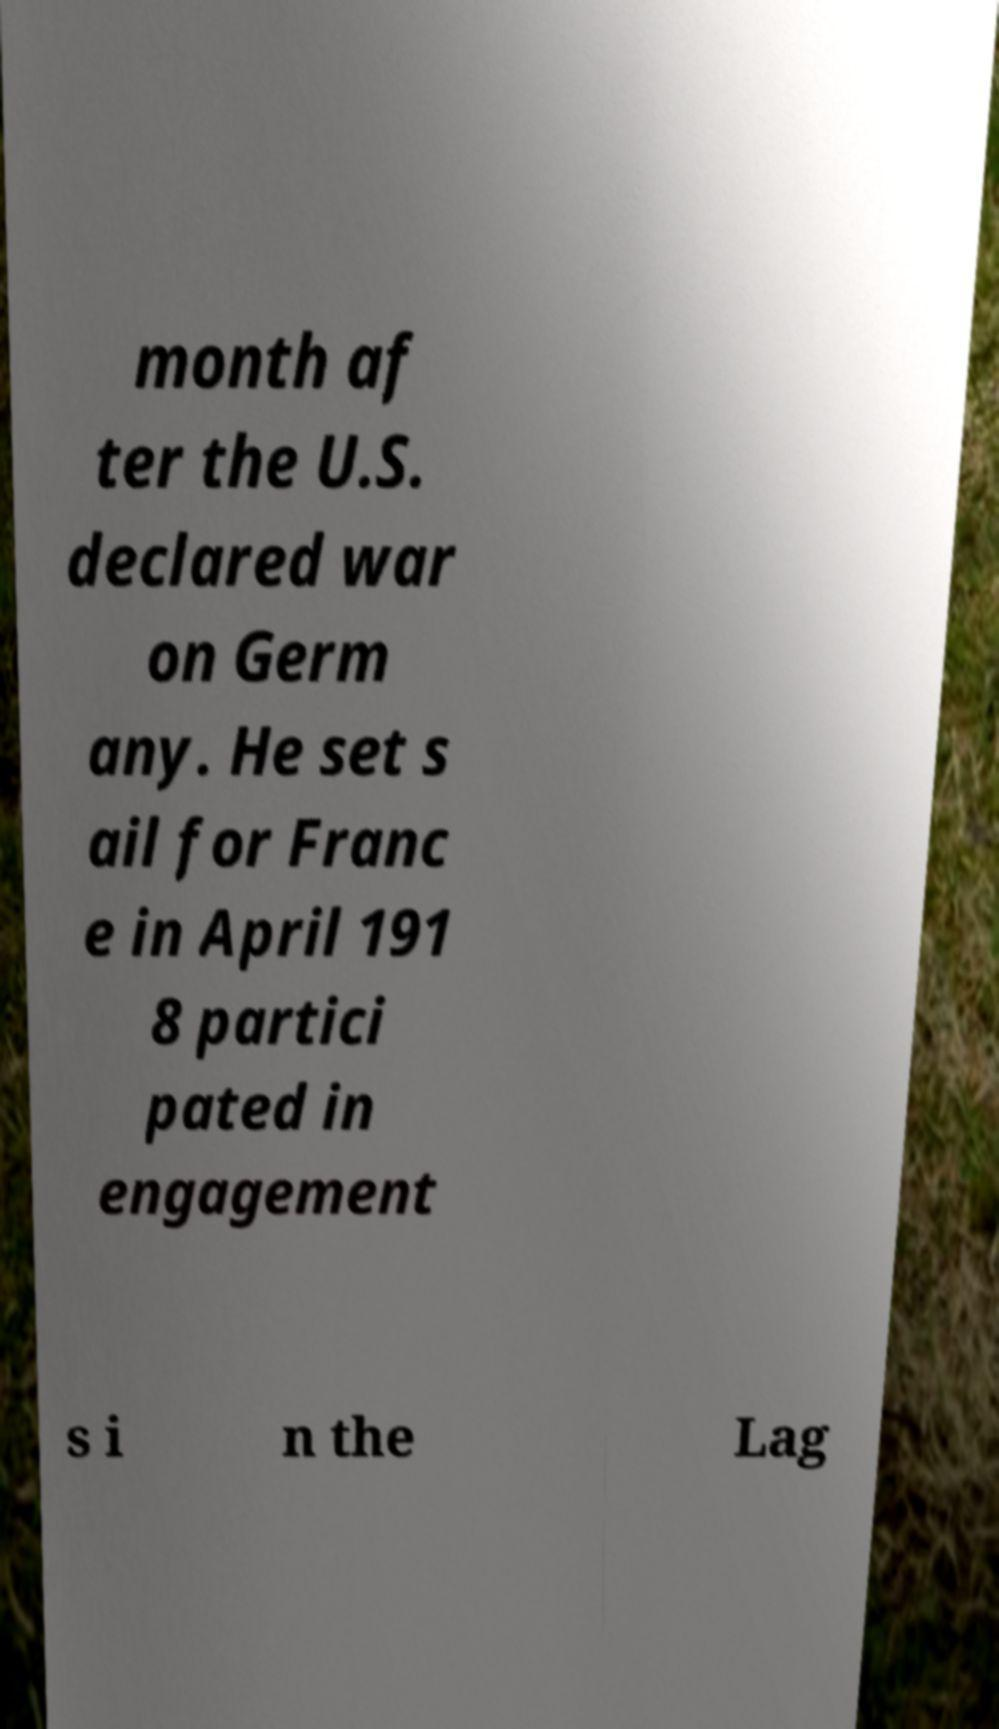For documentation purposes, I need the text within this image transcribed. Could you provide that? month af ter the U.S. declared war on Germ any. He set s ail for Franc e in April 191 8 partici pated in engagement s i n the Lag 